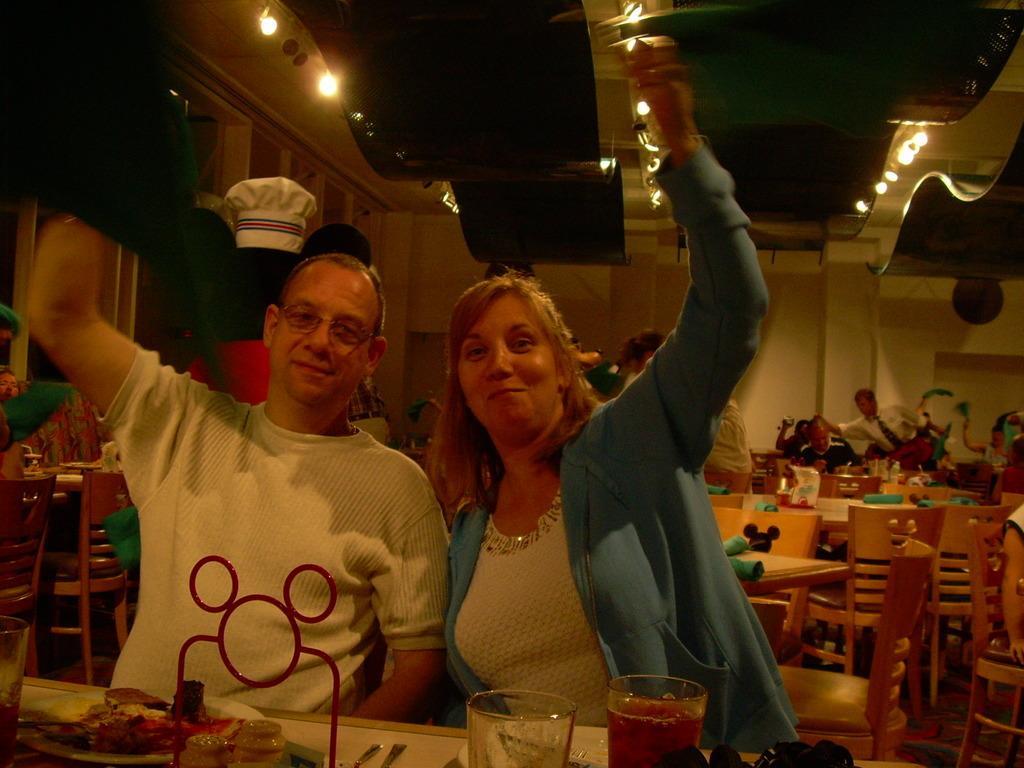Describe this image in one or two sentences. In this image I can see a man and a woman are sitting on chairs. I can also see smile on their faces. On this table I can see food in plates and few glasses. In the background I can see few more chairs, tables and people. 